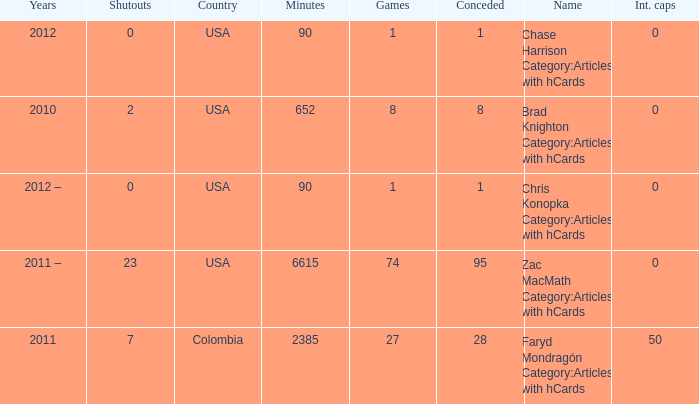When chase harrison category:articles with hcards is the name what is the year? 2012.0. 